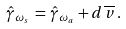Convert formula to latex. <formula><loc_0><loc_0><loc_500><loc_500>\hat { \gamma } _ { \omega _ { s } } \, = \, \hat { \gamma } _ { \omega _ { a } } + d \, \overline { v } \, .</formula> 